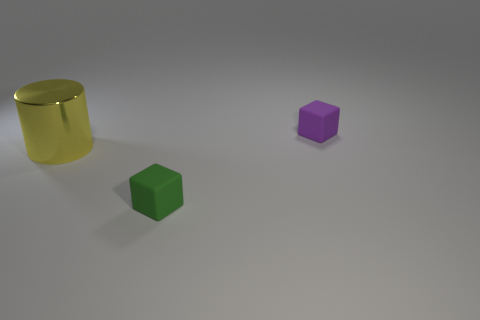Add 2 yellow cylinders. How many objects exist? 5 Subtract all blocks. How many objects are left? 1 Subtract 1 purple cubes. How many objects are left? 2 Subtract all small green metal spheres. Subtract all yellow things. How many objects are left? 2 Add 3 metallic objects. How many metallic objects are left? 4 Add 2 purple cubes. How many purple cubes exist? 3 